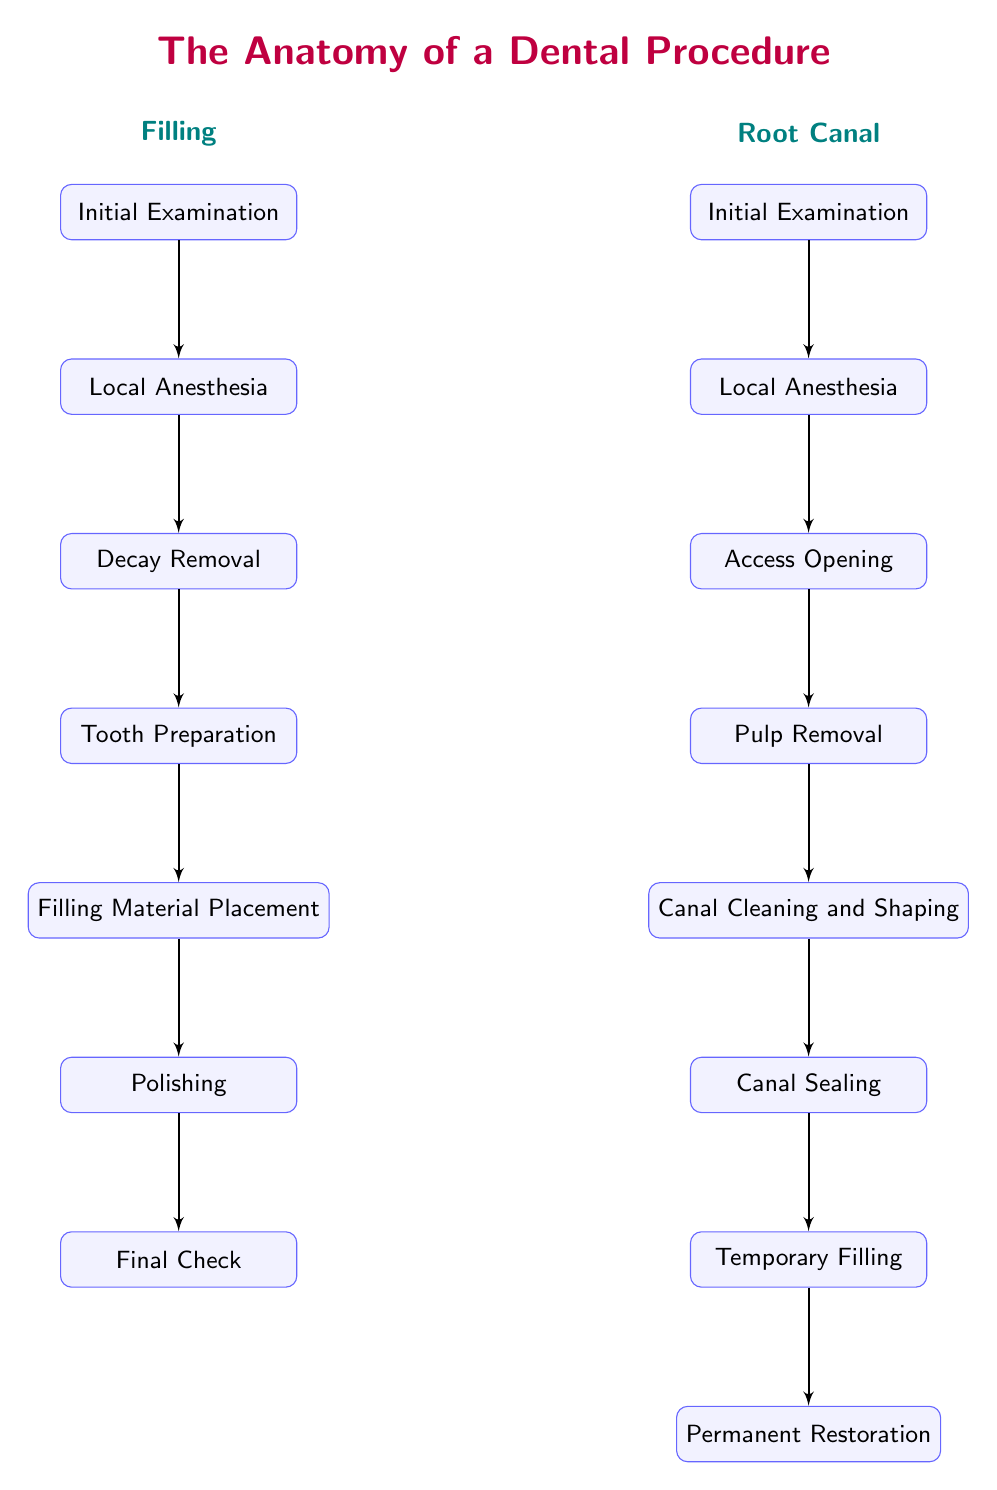What is the first step in the Filling procedure? In the Filling procedure, the first step is labeled "Initial Examination". By examining the diagram, we can see the flow starts from this node at the top of the filling section.
Answer: Initial Examination How many steps are involved in the Root Canal procedure? The Root Canal procedure involves eight steps as shown in the diagram. By counting each block from "Initial Examination" to "Permanent Restoration", we arrive at this total.
Answer: 8 What follows Local Anesthesia in the Filling procedure? After Local Anesthesia, the next step in the Filling procedure is "Decay Removal". This can be determined by following the flow from the Local Anesthesia block to the next block down.
Answer: Decay Removal Which step in the Root Canal procedure is after Canal Sealing? The step that comes after Canal Sealing is "Temporary Filling". This is determined by observing the flow of the diagram directly below the Canal Sealing block.
Answer: Temporary Filling What is the last step of the Filling procedure? The last step of the Filling procedure is "Final Check". This is the final node in the Filling section and can be identified as the bottom-most block in that flowchart.
Answer: Final Check How does the Filling procedure begin? The Filling procedure begins with the "Initial Examination". By observing the diagram, we see that it starts at this point.
Answer: Initial Examination What is the relationship between Decay Removal and Tooth Preparation? The relationship is sequential; "Decay Removal" is the step that occurs immediately before "Tooth Preparation" in the Filling procedure. This is evident by following the flow from one block down to the other.
Answer: Sequential How do the first two steps of both procedures compare? Both procedures share the first two steps: "Initial Examination" and "Local Anesthesia". By comparing the two sections, we can see they are identical.
Answer: Identical 